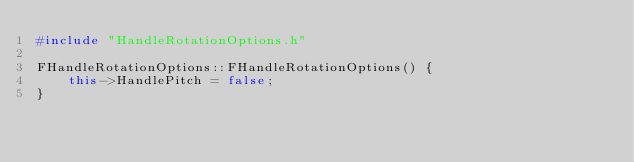Convert code to text. <code><loc_0><loc_0><loc_500><loc_500><_C++_>#include "HandleRotationOptions.h"

FHandleRotationOptions::FHandleRotationOptions() {
    this->HandlePitch = false;
}

</code> 